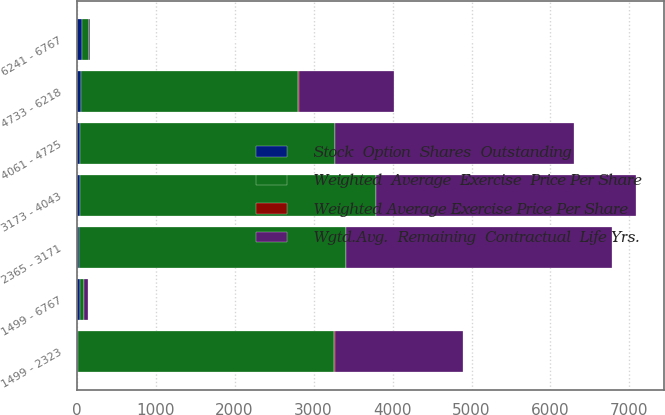Convert chart to OTSL. <chart><loc_0><loc_0><loc_500><loc_500><stacked_bar_chart><ecel><fcel>1499 - 2323<fcel>2365 - 3171<fcel>3173 - 4043<fcel>4061 - 4725<fcel>4733 - 6218<fcel>6241 - 6767<fcel>1499 - 6767<nl><fcel>Weighted  Average  Exercise  Price Per Share<fcel>3238<fcel>3376<fcel>3745<fcel>3224<fcel>2749<fcel>85<fcel>49.98<nl><fcel>Weighted Average Exercise Price Per Share<fcel>4.8<fcel>2.7<fcel>5.1<fcel>6.4<fcel>7.8<fcel>8.3<fcel>5.3<nl><fcel>Stock  Option  Shares  Outstanding<fcel>22.59<fcel>29.62<fcel>39.32<fcel>44.69<fcel>55.27<fcel>65.76<fcel>37.89<nl><fcel>Wgtd.Avg.  Remaining  Contractual  Life Yrs.<fcel>1626<fcel>3371<fcel>3289<fcel>3027<fcel>1205<fcel>5<fcel>49.98<nl></chart> 